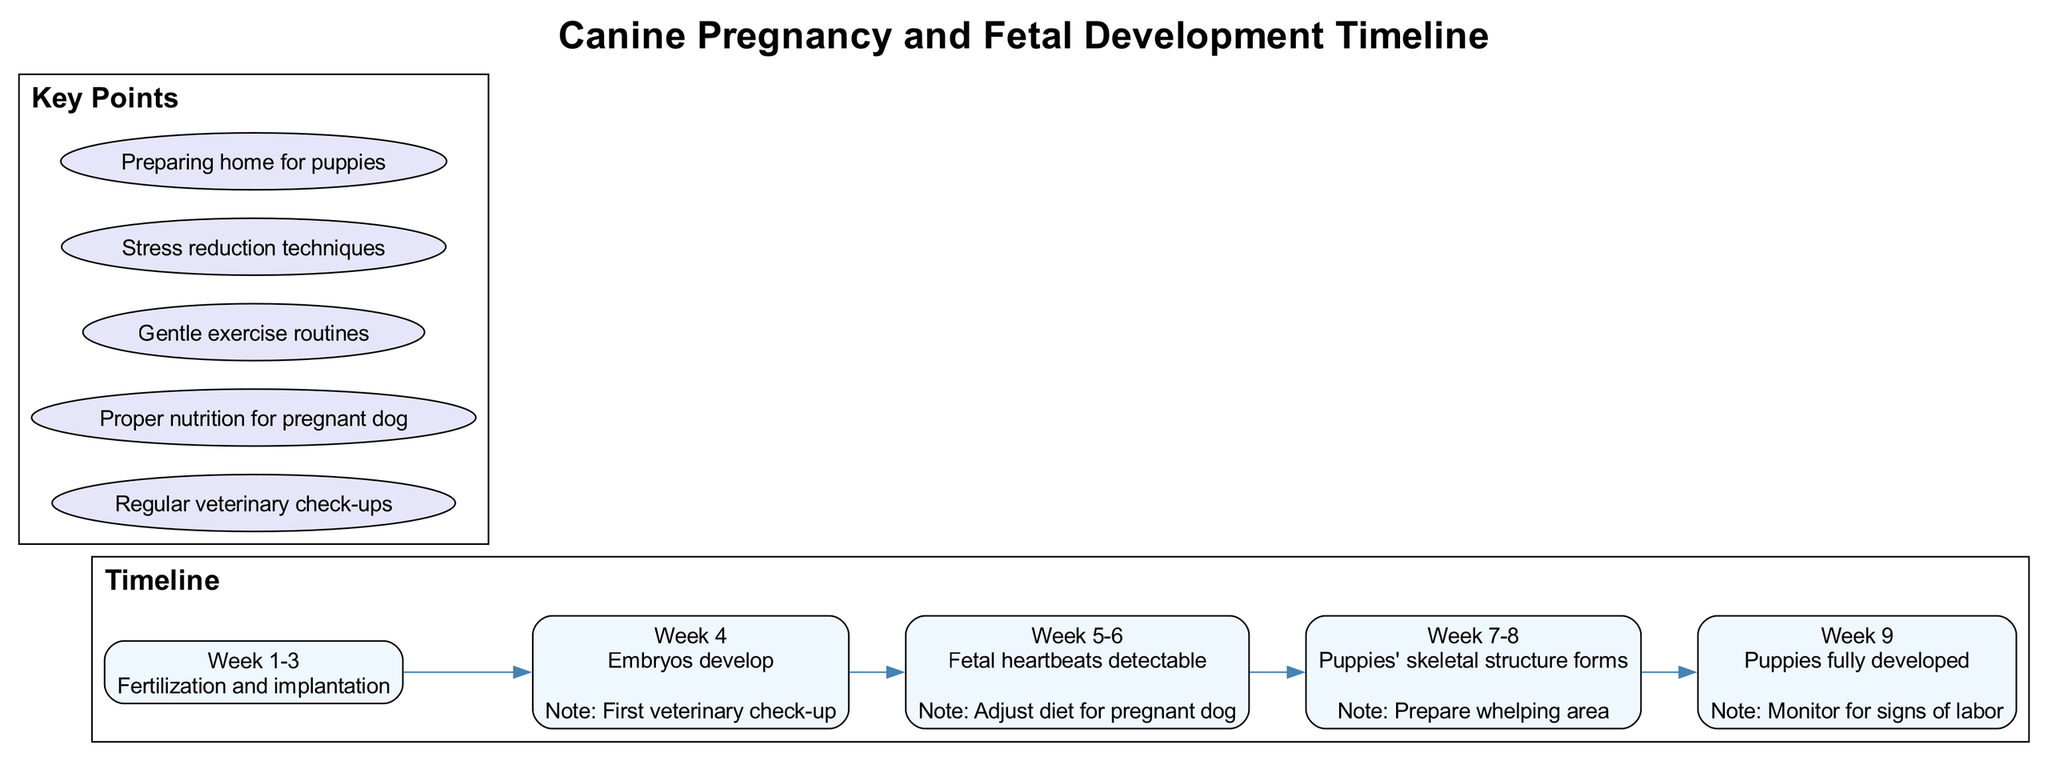What is the first stage of canine pregnancy? The first stage is detailed in the diagram under the 'Week 1-3' node, which describes 'Fertilization and implantation.'
Answer: Fertilization and implantation How many stages are represented in the timeline? By counting each stage listed in the diagram, there are a total of five distinct stages of canine pregnancy and fetal development.
Answer: 5 What happens during Week 9? The diagram specifies that in Week 9, 'Puppies fully developed' is the description provided, indicating that this is when the puppies reach full development.
Answer: Puppies fully developed What should be done during Week 5-6 regarding diet? The diagram notes to 'Adjust diet for pregnant dog' during the Week 5-6 stage, indicating nutrition is important during this time.
Answer: Adjust diet for pregnant dog At which stage is the first veterinary check-up recommended? The first veterinary check-up is indicated in the diagram as occurring during 'Week 4' of the pregnancy timeline.
Answer: Week 4 What is a key point about general care for the pregnant dog? The diagram highlights several key points, one being 'Proper nutrition for pregnant dog' which emphasizes the importance of a good diet throughout the pregnancy.
Answer: Proper nutrition for pregnant dog Which week indicates the formation of puppies' skeletal structure? According to the diagram, the puppies' skeletal structure begins to form during 'Week 7-8.'
Answer: Week 7-8 What is advised to prepare for the puppies' arrival? The diagram states 'Prepare whelping area' as part of the preparations needed, emphasizing the importance of having a suitable environment for the forthcoming puppies.
Answer: Prepare whelping area 